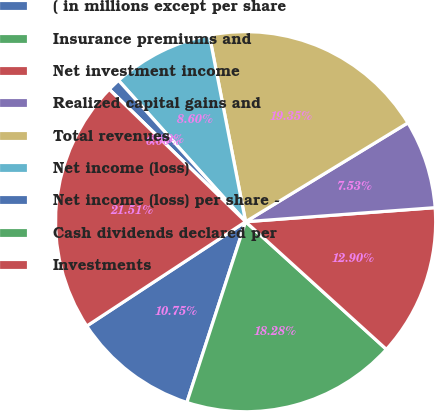<chart> <loc_0><loc_0><loc_500><loc_500><pie_chart><fcel>( in millions except per share<fcel>Insurance premiums and<fcel>Net investment income<fcel>Realized capital gains and<fcel>Total revenues<fcel>Net income (loss)<fcel>Net income (loss) per share -<fcel>Cash dividends declared per<fcel>Investments<nl><fcel>10.75%<fcel>18.28%<fcel>12.9%<fcel>7.53%<fcel>19.35%<fcel>8.6%<fcel>1.08%<fcel>0.0%<fcel>21.51%<nl></chart> 